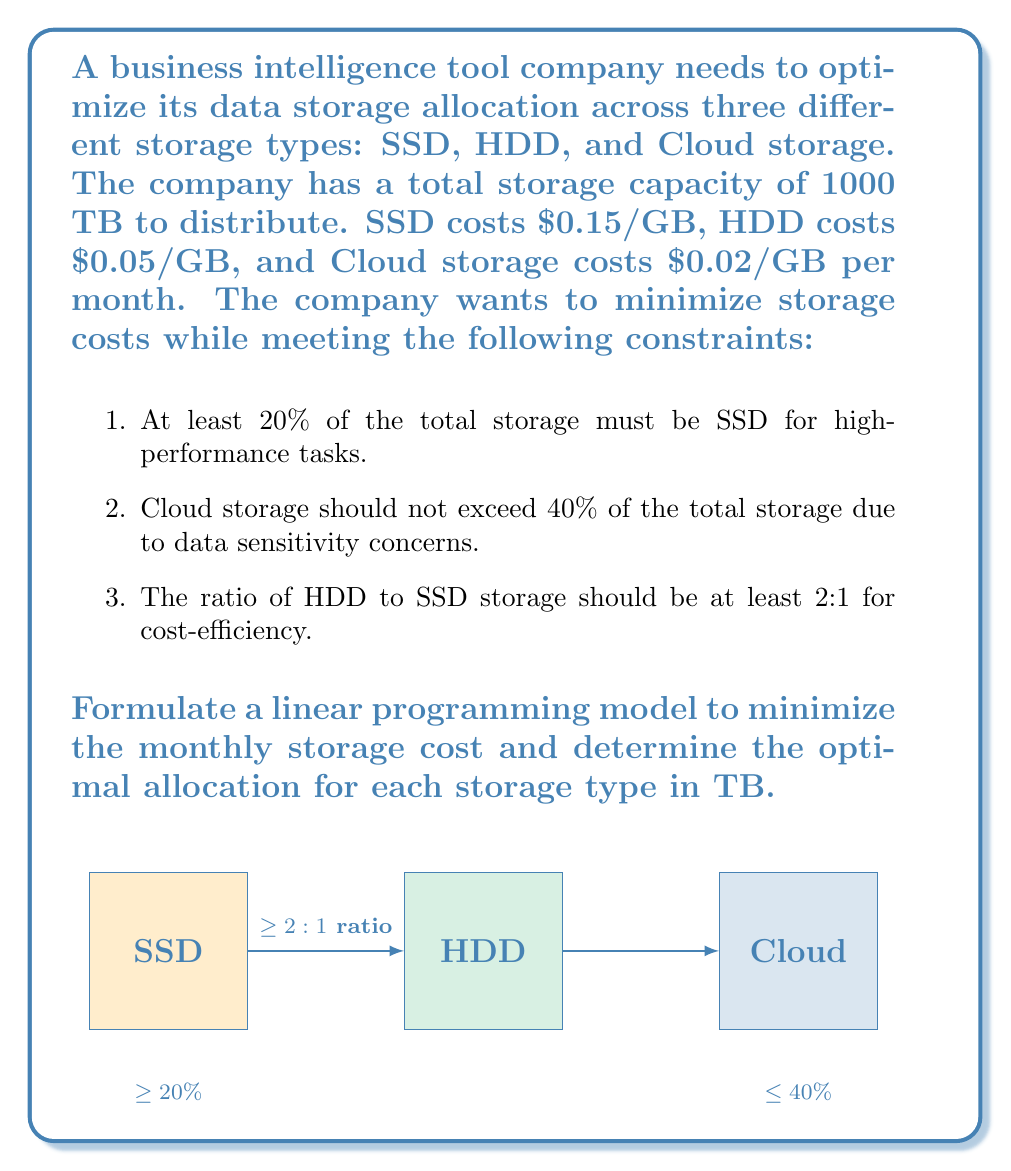Teach me how to tackle this problem. Let's solve this problem step by step:

1) Define variables:
   Let $x$ = SSD storage in TB
   Let $y$ = HDD storage in TB
   Let $z$ = Cloud storage in TB

2) Objective function (minimize monthly cost):
   Minimize $f = 150x + 50y + 20z$ (cost in $/TB)

3) Constraints:
   a) Total storage: $x + y + z = 1000$
   b) SSD at least 20%: $x \geq 0.2(1000) = 200$
   c) Cloud storage at most 40%: $z \leq 0.4(1000) = 400$
   d) HDD to SSD ratio at least 2:1: $y \geq 2x$
   e) Non-negativity: $x, y, z \geq 0$

4) Complete linear programming model:

   Minimize $f = 150x + 50y + 20z$
   Subject to:
   $x + y + z = 1000$
   $x \geq 200$
   $z \leq 400$
   $y \geq 2x$
   $x, y, z \geq 0$

5) Solving the model:
   This model can be solved using the simplex method or linear programming software. The optimal solution is:

   $x = 200$ TB (SSD)
   $y = 400$ TB (HDD)
   $z = 400$ TB (Cloud)

6) Verification:
   - Total storage: $200 + 400 + 400 = 1000$ TB (constraint satisfied)
   - SSD is 20% of total (constraint satisfied)
   - Cloud storage is 40% of total (constraint satisfied)
   - HDD to SSD ratio is 2:1 (constraint satisfied)
   - All values are non-negative (constraint satisfied)

7) Minimum monthly cost:
   $f = 150(200) + 50(400) + 20(400) = 30,000 + 20,000 + 8,000 = $58,000

Therefore, the optimal allocation is 200 TB for SSD, 400 TB for HDD, and 400 TB for Cloud storage, resulting in a minimum monthly cost of $58,000.
Answer: SSD: 200 TB, HDD: 400 TB, Cloud: 400 TB; Cost: $58,000/month 